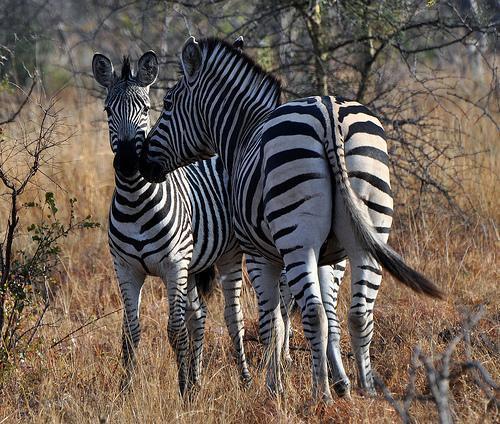How many tails are visible?
Give a very brief answer. 1. How many zebras?
Give a very brief answer. 2. 